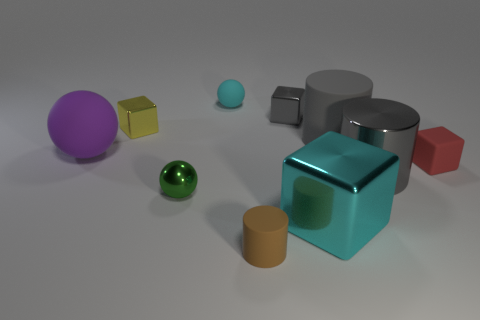How many small objects are either cyan balls or gray rubber things?
Offer a very short reply. 1. How big is the red matte object?
Make the answer very short. Small. There is a green metal thing; is it the same size as the gray object behind the large gray rubber cylinder?
Your response must be concise. Yes. What number of purple things are either small shiny cylinders or tiny blocks?
Make the answer very short. 0. How many tiny green metallic cylinders are there?
Keep it short and to the point. 0. There is a rubber sphere right of the purple object; what size is it?
Keep it short and to the point. Small. Does the purple object have the same size as the green shiny sphere?
Offer a terse response. No. What number of things are either tiny rubber balls or large objects right of the tiny rubber cylinder?
Give a very brief answer. 4. What material is the cyan sphere?
Provide a short and direct response. Rubber. Is there any other thing of the same color as the tiny metal sphere?
Your answer should be compact. No. 